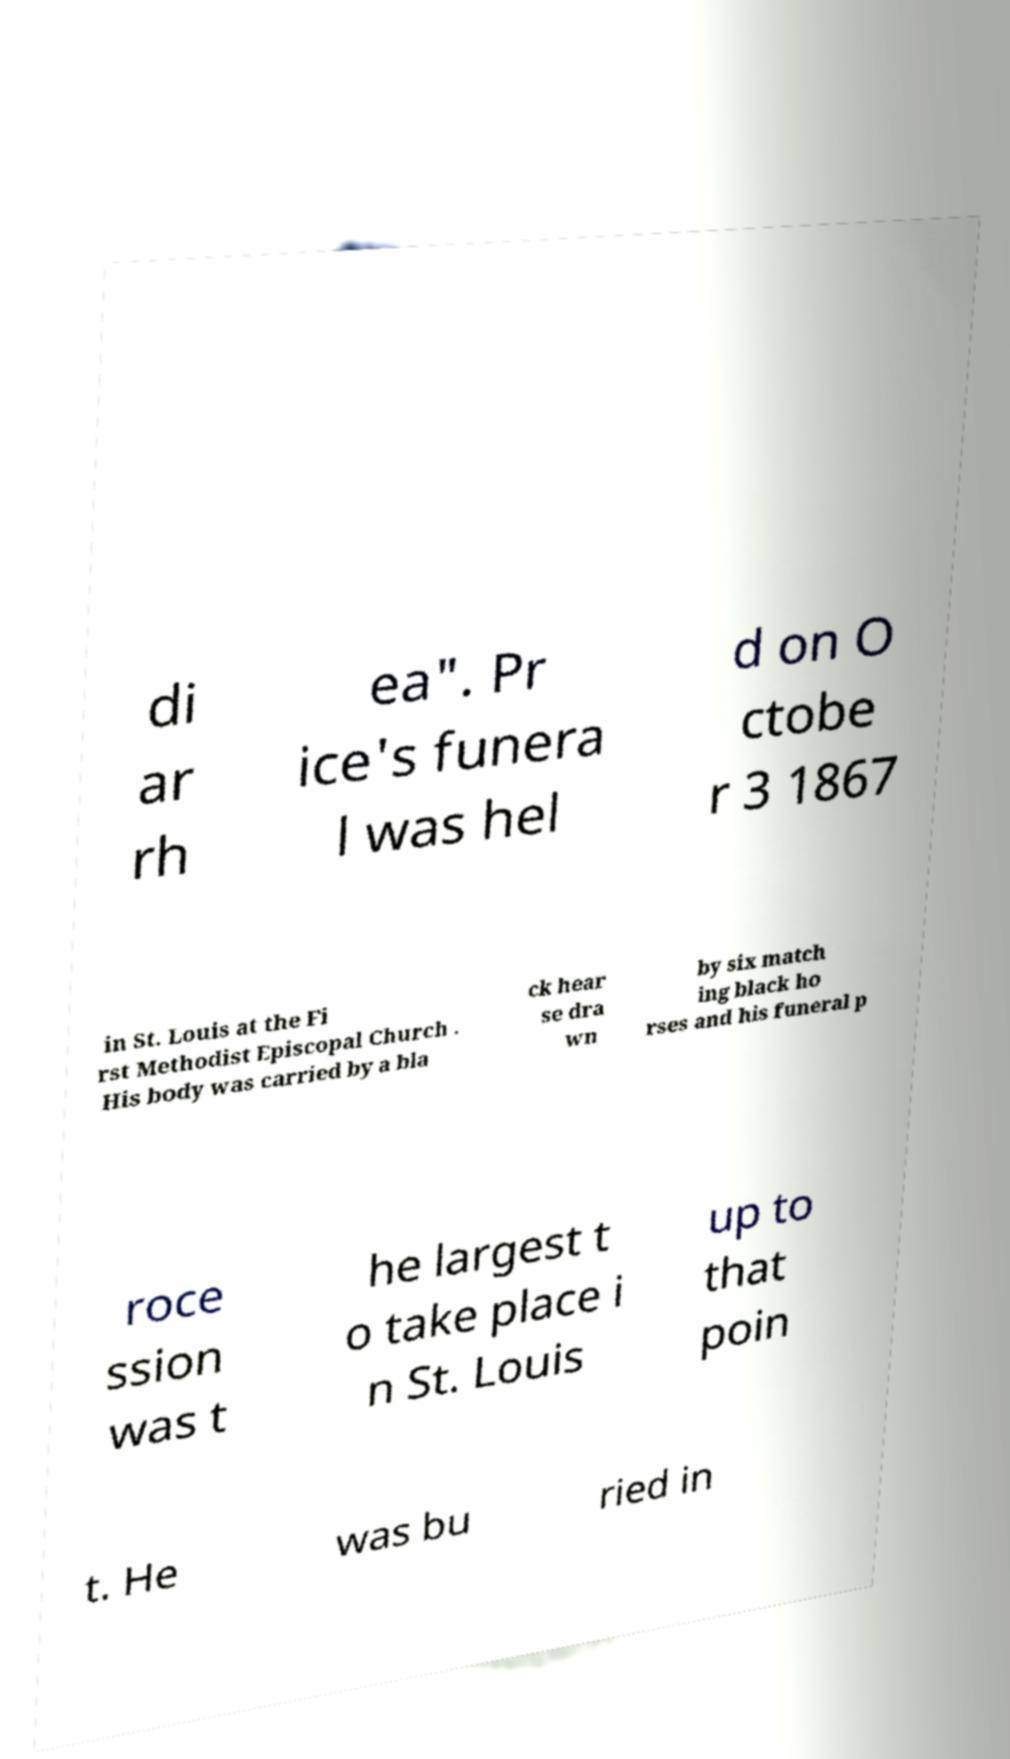There's text embedded in this image that I need extracted. Can you transcribe it verbatim? di ar rh ea". Pr ice's funera l was hel d on O ctobe r 3 1867 in St. Louis at the Fi rst Methodist Episcopal Church . His body was carried by a bla ck hear se dra wn by six match ing black ho rses and his funeral p roce ssion was t he largest t o take place i n St. Louis up to that poin t. He was bu ried in 